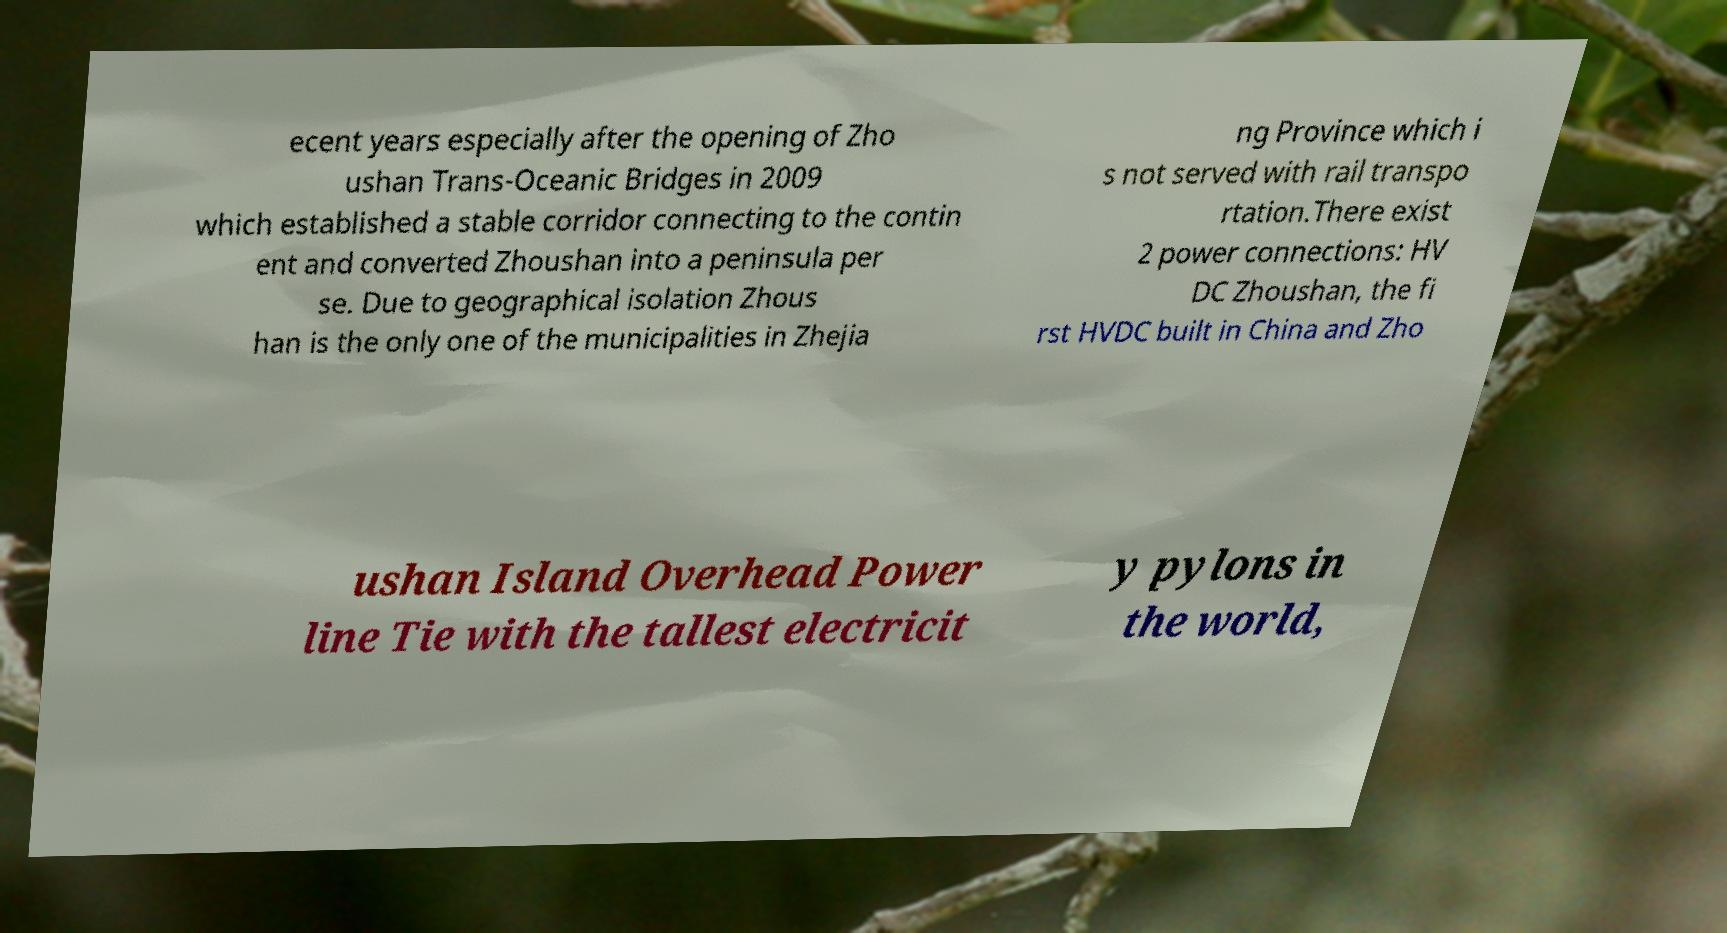I need the written content from this picture converted into text. Can you do that? ecent years especially after the opening of Zho ushan Trans-Oceanic Bridges in 2009 which established a stable corridor connecting to the contin ent and converted Zhoushan into a peninsula per se. Due to geographical isolation Zhous han is the only one of the municipalities in Zhejia ng Province which i s not served with rail transpo rtation.There exist 2 power connections: HV DC Zhoushan, the fi rst HVDC built in China and Zho ushan Island Overhead Power line Tie with the tallest electricit y pylons in the world, 